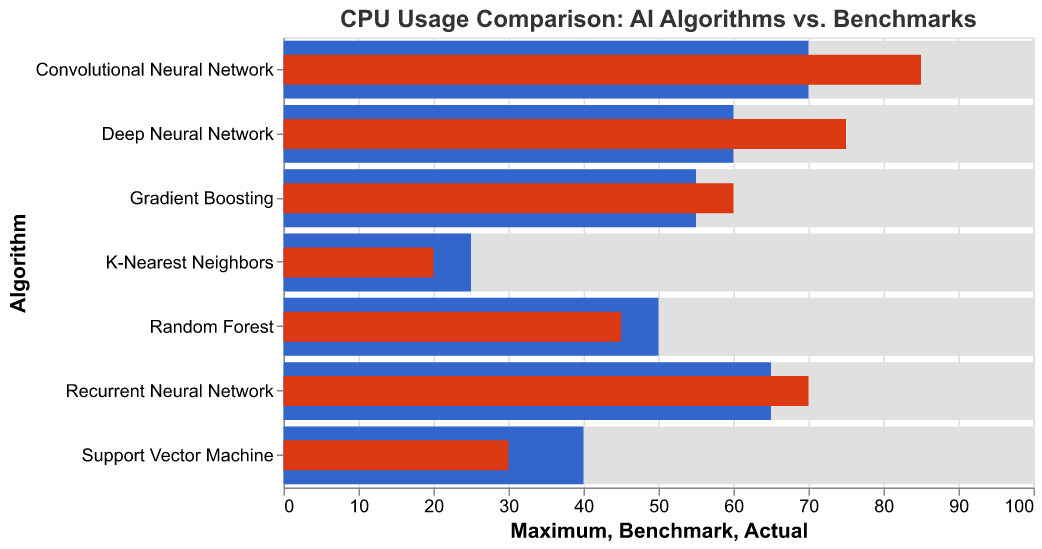What is the title of the figure? The title of the figure is written at the top and it is "CPU Usage Comparison: AI Algorithms vs. Benchmarks"
Answer: CPU Usage Comparison: AI Algorithms vs. Benchmarks What does the color grey represent in the figure? The grey color represents the "Maximum" CPU usage for each AI algorithm, as seen in the background bar.
Answer: Maximum CPU usage Which AI algorithm has the highest actual CPU usage? The Convolutional Neural Network has the highest actual CPU usage at 85, as indicated by the tallest red bar.
Answer: Convolutional Neural Network Which algorithm has an actual CPU usage lower than its benchmark CPU usage? By comparing the blue and red bars, we see that for the Random Forest, the actual CPU usage (45) is lower than its benchmark (50).
Answer: Random Forest What is the difference between the actual and the benchmark CPU usage for Deep Neural Network? For the Deep Neural Network, the actual CPU usage is 75 and the benchmark is 60. The difference is 75 - 60 = 15.
Answer: 15 What is the average actual CPU usage across all AI algorithms? Add up all the actual CPU usages (75+45+30+60+20+85+70) and divide by the number of algorithms (7). (75+45+30+60+20+85+70) / 7 = 55
Answer: 55 Which algorithm comes closest to meeting its benchmark CPU usage? Compare the differences between actual and benchmark CPU values; Gradient Boosting has an actual CPU usage of 60 and a benchmark of 55, difference is 60 - 55 = 5, which is the smallest difference.
Answer: Gradient Boosting What percentage of the maximum CPU usage does the actual usage of Support Vector Machine represent? The actual CPU usage for Support Vector Machine is 30, and the maximum is 100. The percentage is (30 / 100) * 100% = 30%
Answer: 30% Arrange the algorithms in descending order based on their benchmark CPU usage. List the benchmark values and arrange them: Convolutional Neural Network (70), Recurrent Neural Network (65), Deep Neural Network (60), Gradient Boosting (55), Random Forest (50), Support Vector Machine (40), K-Nearest Neighbors (25)
Answer: Convolutional Neural Network, Recurrent Neural Network, Deep Neural Network, Gradient Boosting, Random Forest, Support Vector Machine, K-Nearest Neighbors What is the median actual CPU usage for the algorithms? Order the actual CPU values: 20, 30, 45, 60, 70, 75, 85. The middle (median) value in this list is 60.
Answer: 60 